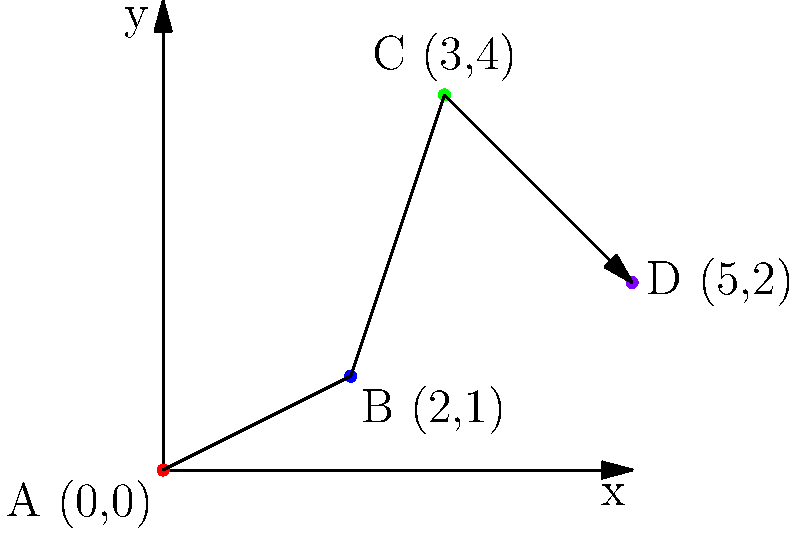In your latest novel, you've plotted the journey of your protagonist on a coordinate plane. The character starts at point A (0,0), travels through points B (2,1) and C (3,4), and ends at point D (5,2). What is the total distance traveled by the character, rounded to two decimal places? To find the total distance traveled, we need to calculate the length of each segment of the journey and sum them up. We can use the distance formula between two points: $d = \sqrt{(x_2-x_1)^2 + (y_2-y_1)^2}$

1. Distance from A to B:
   $d_{AB} = \sqrt{(2-0)^2 + (1-0)^2} = \sqrt{4 + 1} = \sqrt{5} \approx 2.24$

2. Distance from B to C:
   $d_{BC} = \sqrt{(3-2)^2 + (4-1)^2} = \sqrt{1 + 9} = \sqrt{10} \approx 3.16$

3. Distance from C to D:
   $d_{CD} = \sqrt{(5-3)^2 + (2-4)^2} = \sqrt{4 + 4} = \sqrt{8} \approx 2.83$

4. Total distance:
   $d_{total} = d_{AB} + d_{BC} + d_{CD} \approx 2.24 + 3.16 + 2.83 = 8.23$

Rounding to two decimal places, we get 8.23 units.
Answer: 8.23 units 